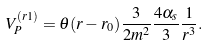Convert formula to latex. <formula><loc_0><loc_0><loc_500><loc_500>V _ { P } ^ { ( r 1 ) } = \theta ( r - r _ { 0 } ) { \frac { 3 } { 2 m ^ { 2 } } } { \frac { 4 \alpha _ { s } } { 3 } } { \frac { 1 } { r ^ { 3 } } } .</formula> 